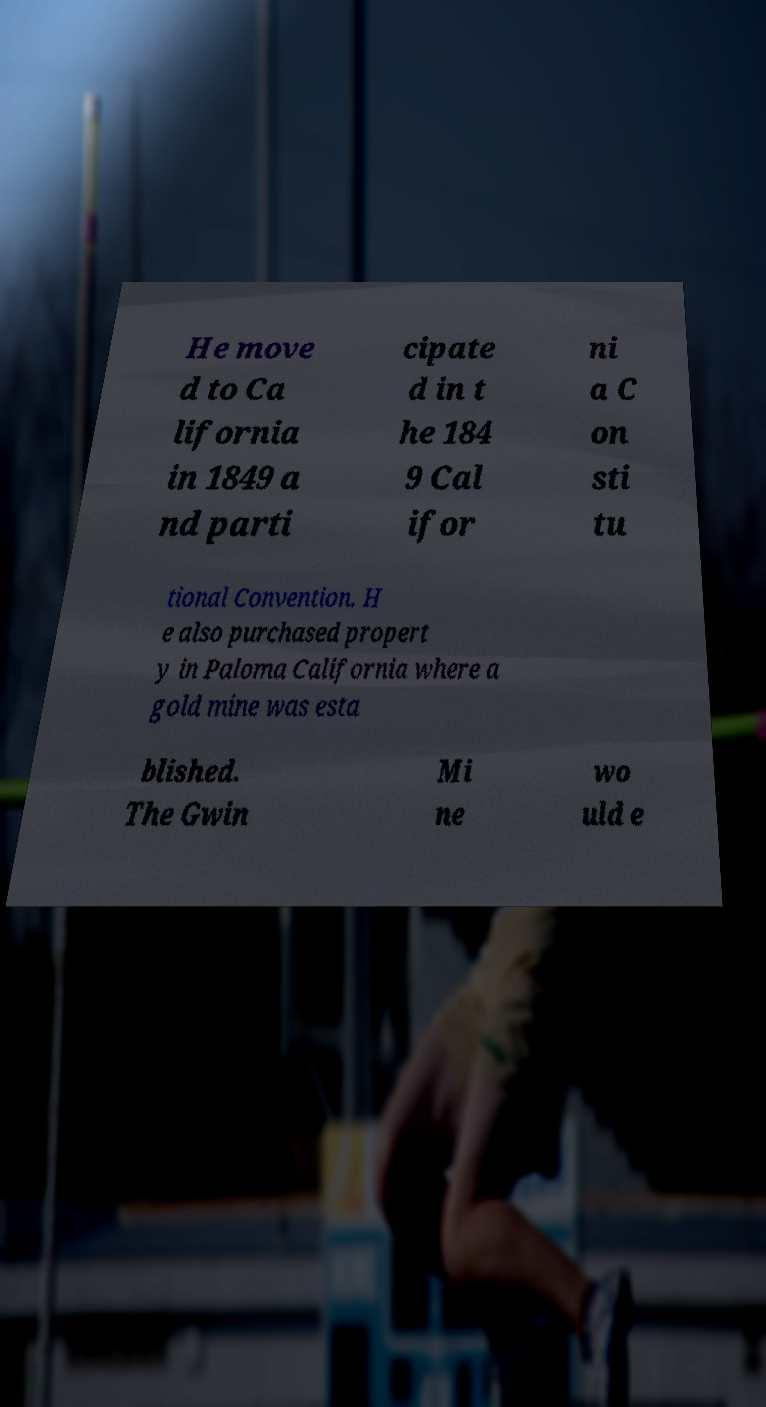For documentation purposes, I need the text within this image transcribed. Could you provide that? He move d to Ca lifornia in 1849 a nd parti cipate d in t he 184 9 Cal ifor ni a C on sti tu tional Convention. H e also purchased propert y in Paloma California where a gold mine was esta blished. The Gwin Mi ne wo uld e 